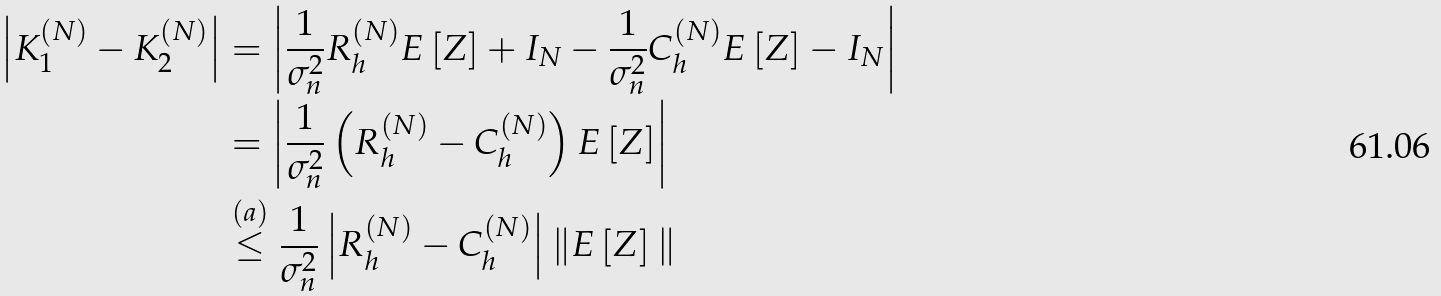Convert formula to latex. <formula><loc_0><loc_0><loc_500><loc_500>\left | K _ { 1 } ^ { ( N ) } - K _ { 2 } ^ { ( N ) } \right | & = \left | \frac { 1 } { \sigma _ { n } ^ { 2 } } R _ { h } ^ { ( N ) } E \left [ Z \right ] + I _ { N } - \frac { 1 } { \sigma _ { n } ^ { 2 } } C _ { h } ^ { ( N ) } E \left [ Z \right ] - I _ { N } \right | \\ & = \left | \frac { 1 } { \sigma _ { n } ^ { 2 } } \left ( R _ { h } ^ { ( N ) } - C _ { h } ^ { ( N ) } \right ) E \left [ Z \right ] \right | \\ & \stackrel { ( a ) } { \leq } \frac { 1 } { \sigma _ { n } ^ { 2 } } \left | R _ { h } ^ { ( N ) } - C _ { h } ^ { ( N ) } \right | \| E \left [ Z \right ] \|</formula> 